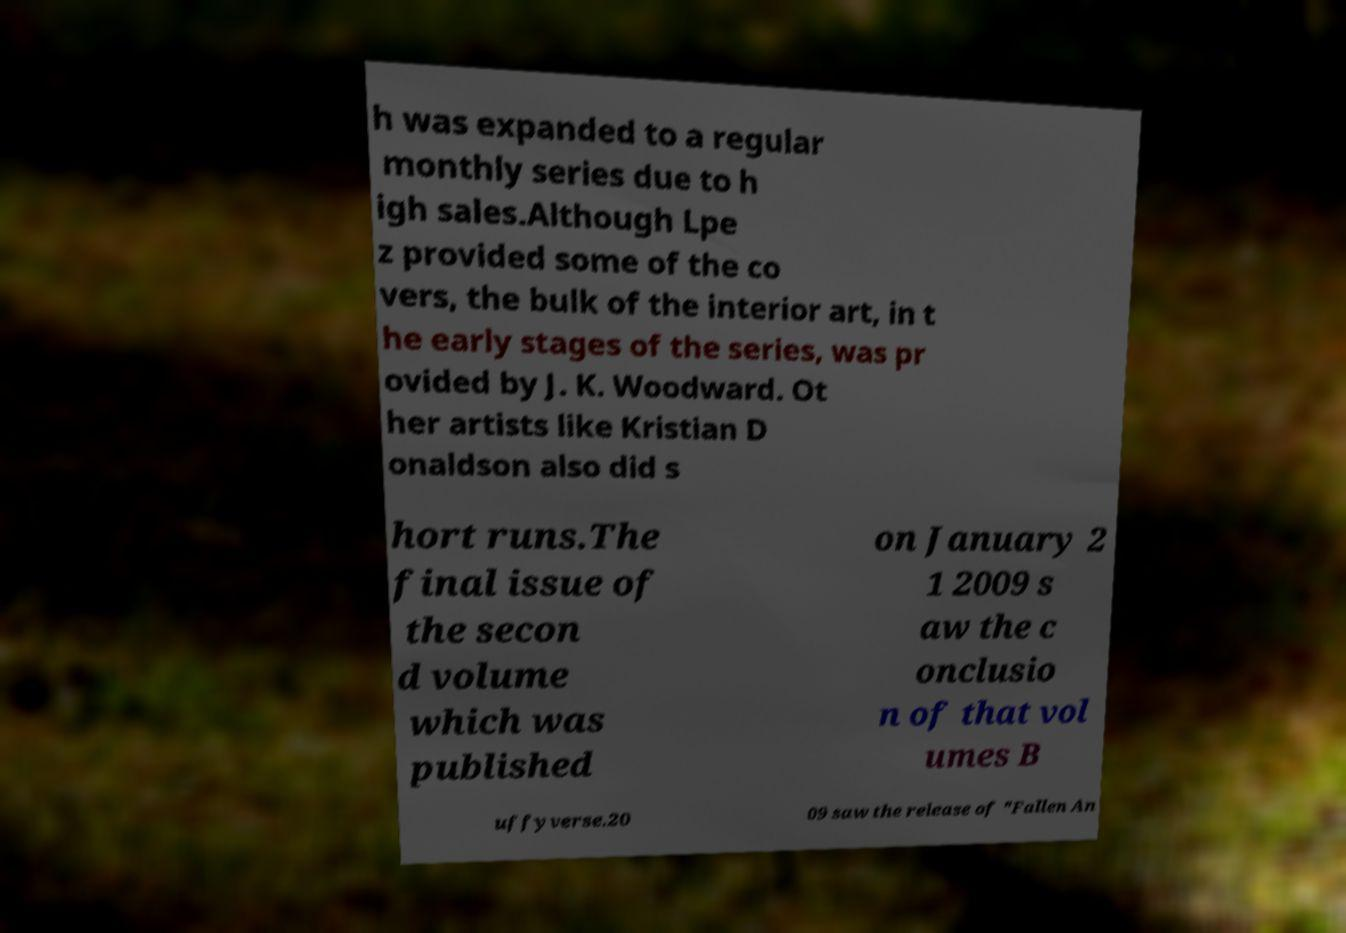I need the written content from this picture converted into text. Can you do that? h was expanded to a regular monthly series due to h igh sales.Although Lpe z provided some of the co vers, the bulk of the interior art, in t he early stages of the series, was pr ovided by J. K. Woodward. Ot her artists like Kristian D onaldson also did s hort runs.The final issue of the secon d volume which was published on January 2 1 2009 s aw the c onclusio n of that vol umes B uffyverse.20 09 saw the release of "Fallen An 